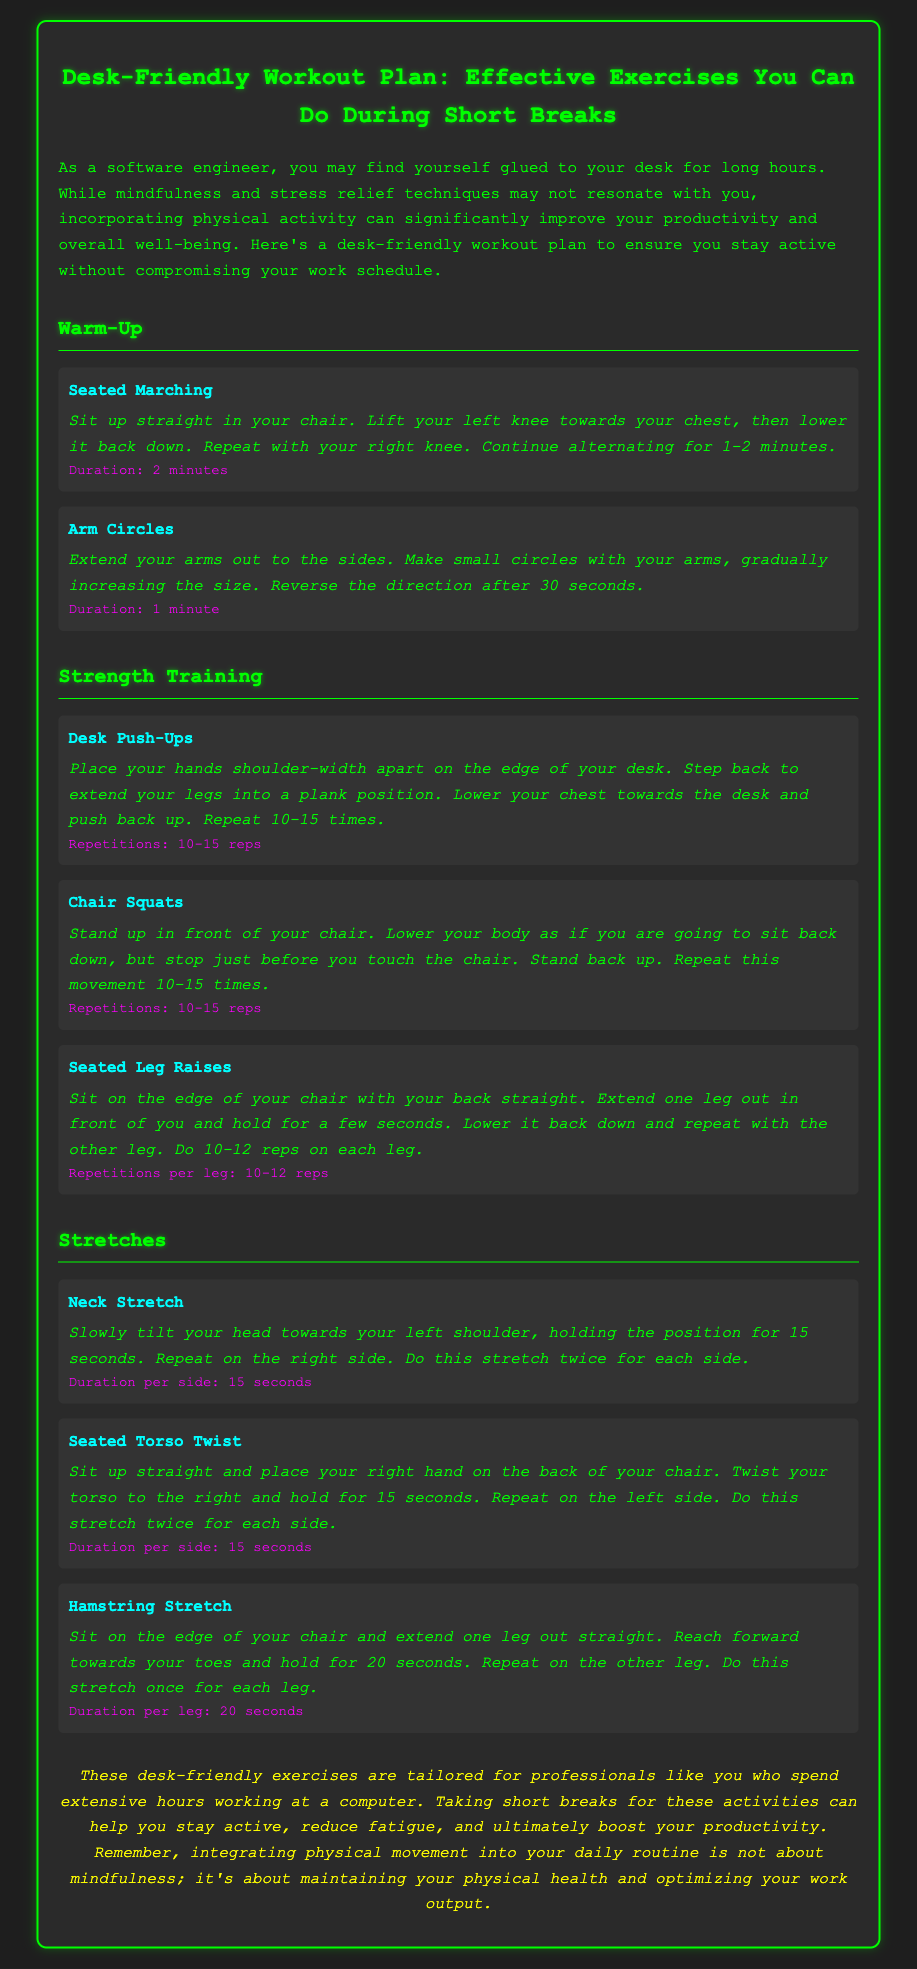what is the title of the document? The title of the document is displayed prominently at the top of the rendered output.
Answer: Desk-Friendly Workout Plan: Effective Exercises You Can Do During Short Breaks how long should the 'Seated Marching' exercise be performed? The duration for the 'Seated Marching' exercise is stated in the instructions for that specific exercise.
Answer: 2 minutes how many repetitions are recommended for 'Desk Push-Ups'? The number of repetitions for 'Desk Push-Ups' is mentioned directly under the exercise instructions.
Answer: 10-15 reps how many times should you repeat the 'Neck Stretch' on each side? The number of repetitions for the 'Neck Stretch' is specified in the exercise instructions.
Answer: Twice what is the main purpose of this workout plan? The main purpose of the workout plan is highlighted in the introduction paragraph at the beginning of the document.
Answer: To ensure you stay active without compromising your work schedule why are desk-friendly exercises important for professionals? The importance of these exercises for professionals is explained in the conclusion of the document.
Answer: To reduce fatigue and ultimately boost your productivity 